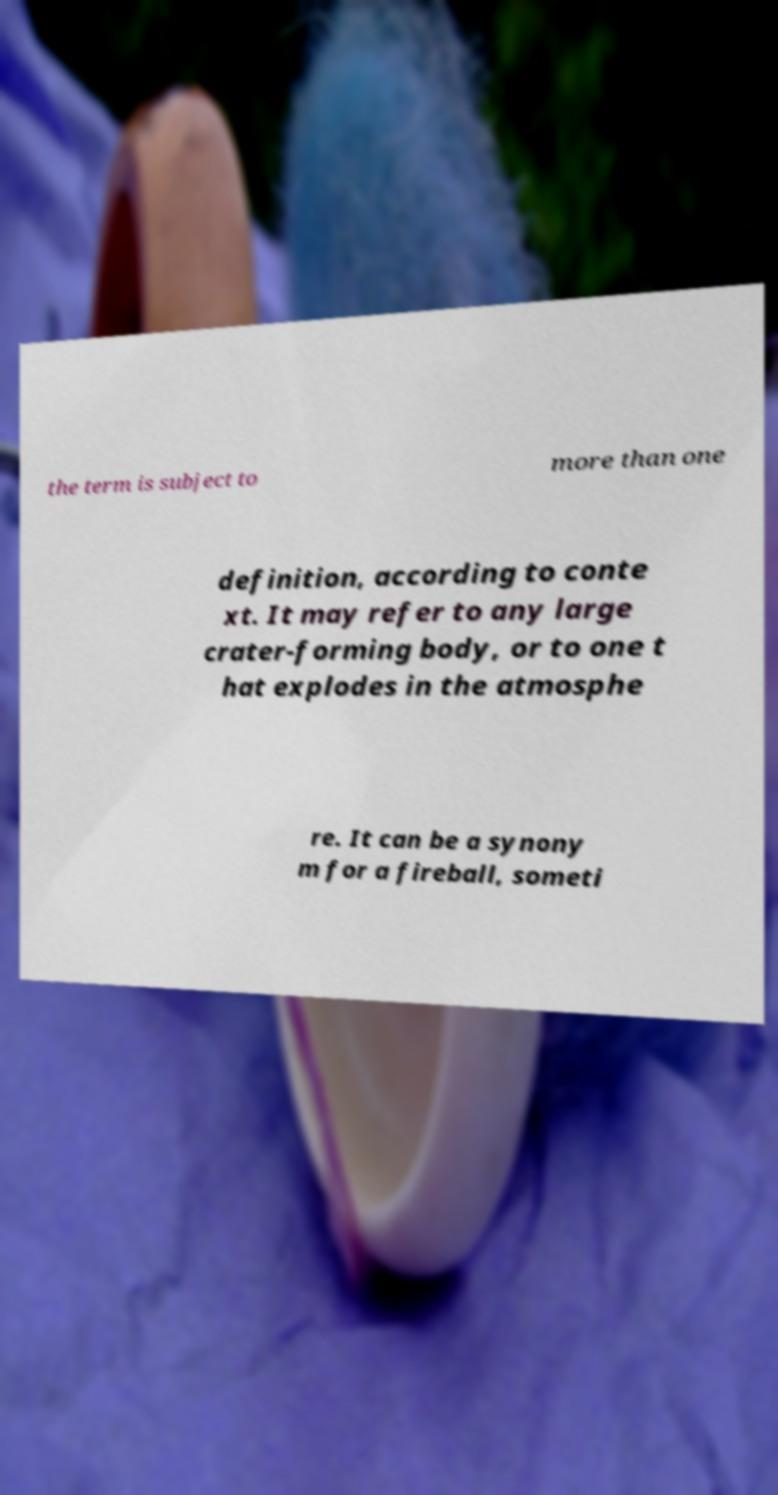Please read and relay the text visible in this image. What does it say? the term is subject to more than one definition, according to conte xt. It may refer to any large crater-forming body, or to one t hat explodes in the atmosphe re. It can be a synony m for a fireball, someti 